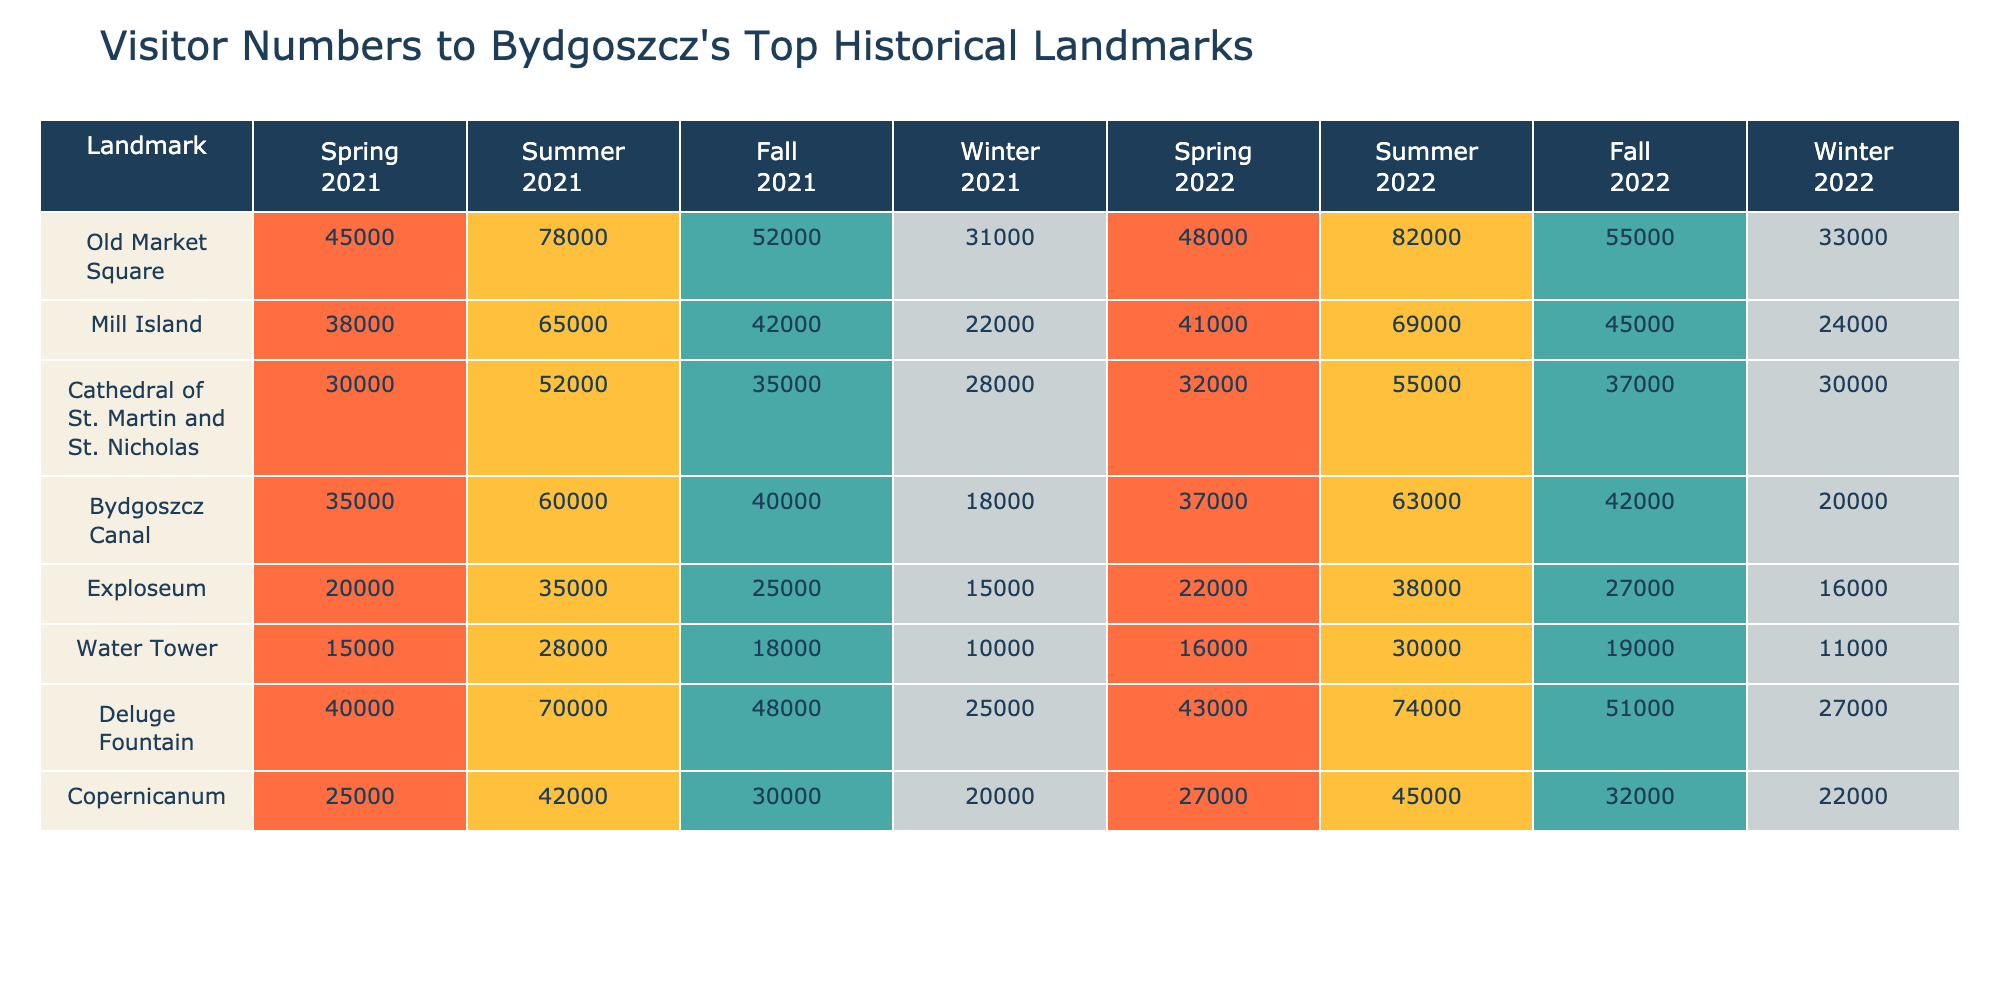What was the highest number of visitors to the Old Market Square in Summer 2021? Referring to the table, the number of visitors to the Old Market Square in Summer 2021 is given as 78,000, which is the highest for that season among the landmarks.
Answer: 78,000 Which landmark had the lowest visitor numbers in Winter 2022? Looking at the table, the Water Tower had the lowest number of visitors in Winter 2022 with 11,000 visitors.
Answer: 11,000 What is the total number of visitors to the Deluge Fountain across all seasons in 2021? The total visitors to the Deluge Fountain for 2021 are calculated as follows: 40,000 (Spring) + 70,000 (Summer) + 48,000 (Fall) + 25,000 (Winter) = 183,000.
Answer: 183,000 Was the visitor count for the Bydgoszcz Canal higher in Fall 2021 or Fall 2022? The visitor count for Bydgoszcz Canal in Fall 2021 is 40,000 while in Fall 2022 it is 42,000. Since 42,000 is greater than 40,000, Fall 2022 had a higher count.
Answer: Yes What is the average number of visitors to Mill Island over the two-year period? To find the average for Mill Island, sum the visitors from each season over the two years: (38,000 + 65,000 + 42,000 + 22,000 + 41,000 + 69,000 + 45,000 + 24,000) = 342,000. Then, divide by the number of seasons (8), resulting in 342,000 / 8 = 42,750.
Answer: 42,750 Which landmark has the highest overall visitor number for both years combined? Adding up the visitors for each landmark across all seasons gives: Old Market Square: 45000 + 78000 + 52000 + 31000 + 48000 + 82000 + 55000 + 33000 = 29,000; Mill Island: 38,000 + 65,000 + 42,000 + 22,000 + 41,000 + 69,000 + 45,000 + 24,000 = 342,000; ... Comparing all, Old Market Square has the highest at 328,000.
Answer: Old Market Square In which season did the Cathedral of St. Martin and St. Nicholas have the most visitors in 2022? Checking the visitor figures for 2022, for the Cathedral of St. Martin and St. Nicholas, the highest number was in Summer with 55,000 visitors compared to 32,000 in Spring, 37,000 in Fall, and 30,000 in Winter.
Answer: Summer By how much did the Winter 2021 visitor numbers for the Water Tower differ from Winter 2022? The visitor count for Water Tower in Winter 2021 is 10,000, while in Winter 2022 it is 11,000. The difference is 11,000 - 10,000 = 1,000, indicating an increase.
Answer: 1,000 What percentage of visitors to Exploseum in Summer 2022 does the number of visitors in Winter 2022 represent? The visitors to Exploseum in Summer 2022 were 38,000 and in Winter 2022 it was 16,000. The percentage calculation is (16,000 / 38,000) * 100 = 42.11%, indicating Winter 2022 has about 42.11% of Summer's visitors.
Answer: 42.11% 